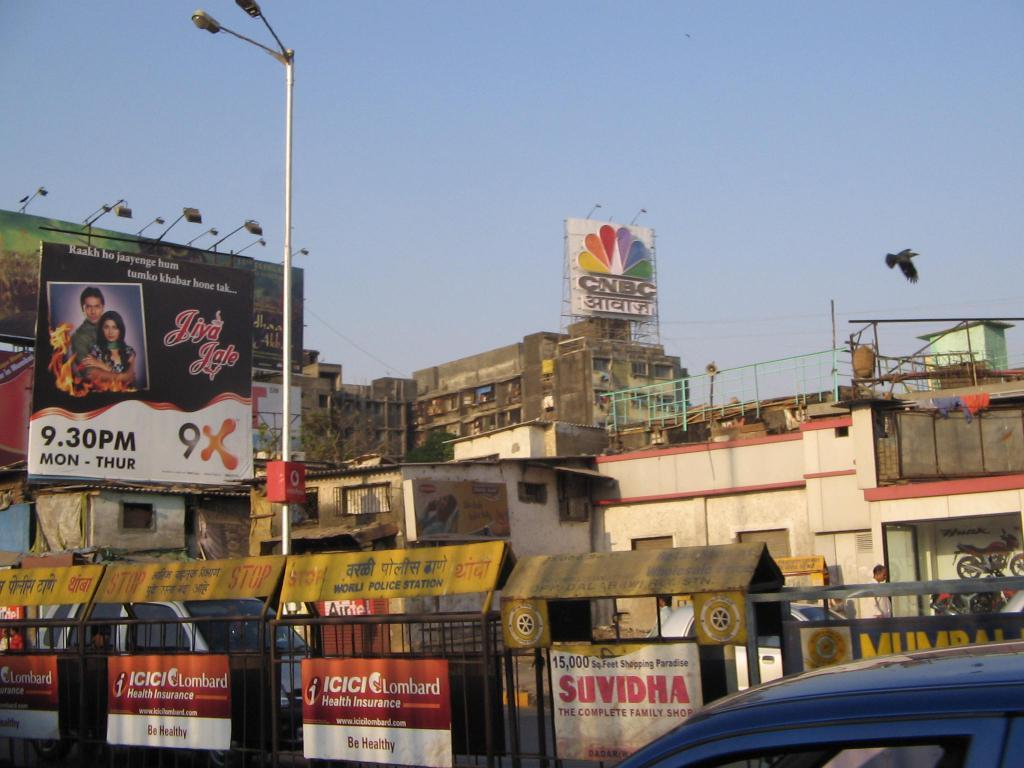<image>
Provide a brief description of the given image. A health insurance sign says to be healthy. 